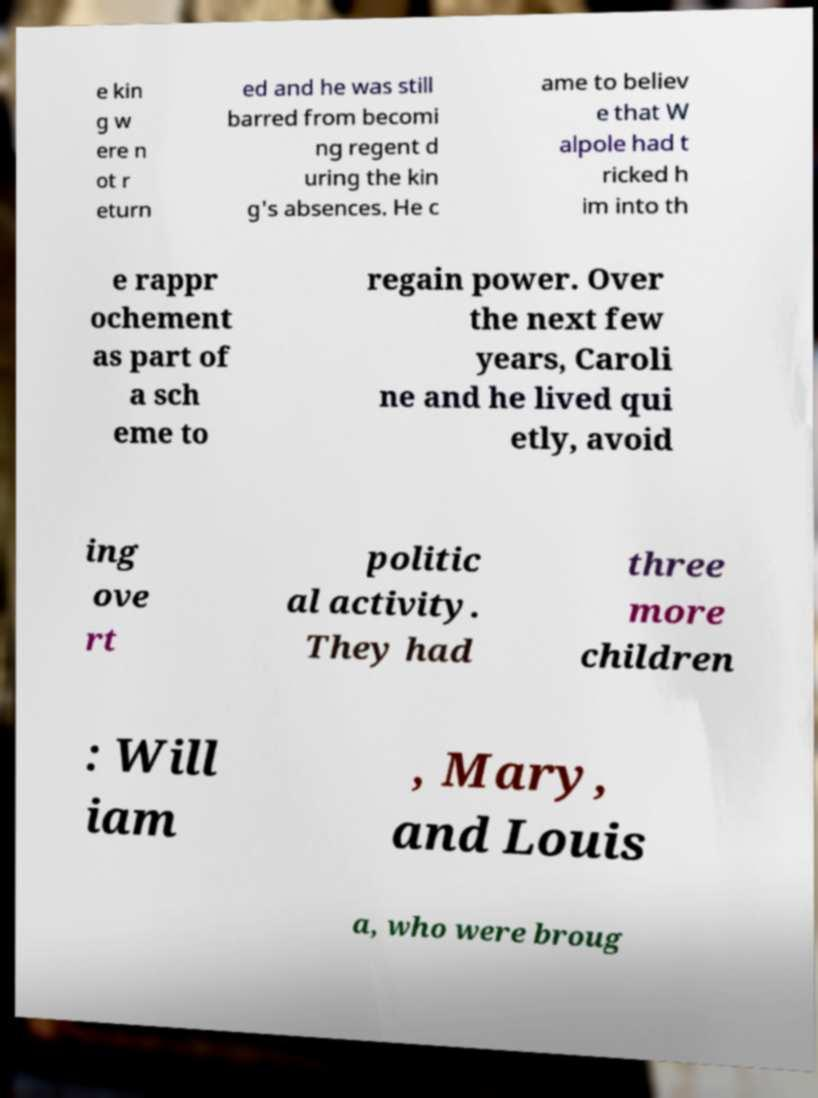Can you read and provide the text displayed in the image?This photo seems to have some interesting text. Can you extract and type it out for me? e kin g w ere n ot r eturn ed and he was still barred from becomi ng regent d uring the kin g's absences. He c ame to believ e that W alpole had t ricked h im into th e rappr ochement as part of a sch eme to regain power. Over the next few years, Caroli ne and he lived qui etly, avoid ing ove rt politic al activity. They had three more children : Will iam , Mary, and Louis a, who were broug 